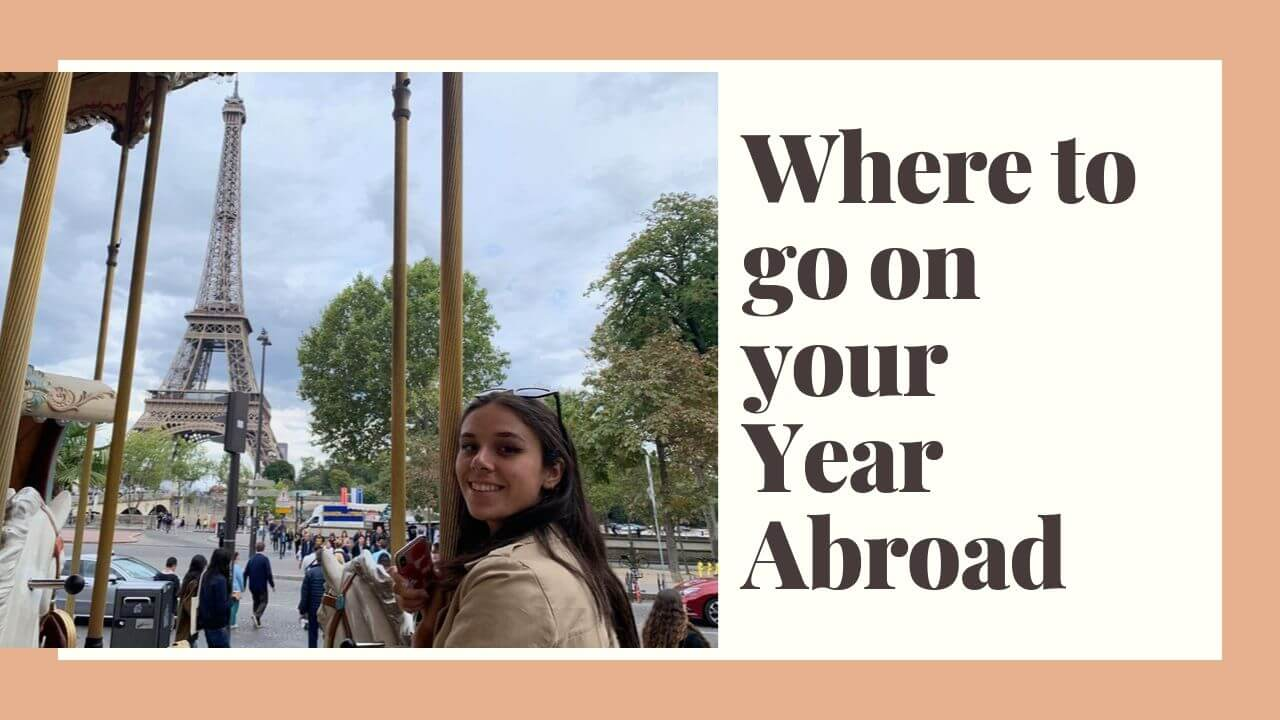Imagine this scene from the perspective of someone in the middle of their exciting year abroad. Describe their feelings and thoughts. Standing before the Eiffel Tower, the majestic symbol of Paris, she grips the carousel pole with a mixture of anticipation and joy. It's been a whirlwind few months of discovery and growth. She thinks about the friendships she's formed, the new foods she's tasted, and the countless moments that have expanded her view of the world. With a broad smile, she feels a deep sense of fulfillment and pride. This year abroad, which once seemed like a distant dream, has become the most enriching chapter of her life. 